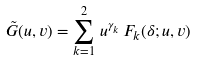Convert formula to latex. <formula><loc_0><loc_0><loc_500><loc_500>\tilde { G } ( u , v ) = \sum _ { k = 1 } ^ { 2 } \, u ^ { \gamma _ { k } } \, F _ { k } ( \delta ; u , v )</formula> 